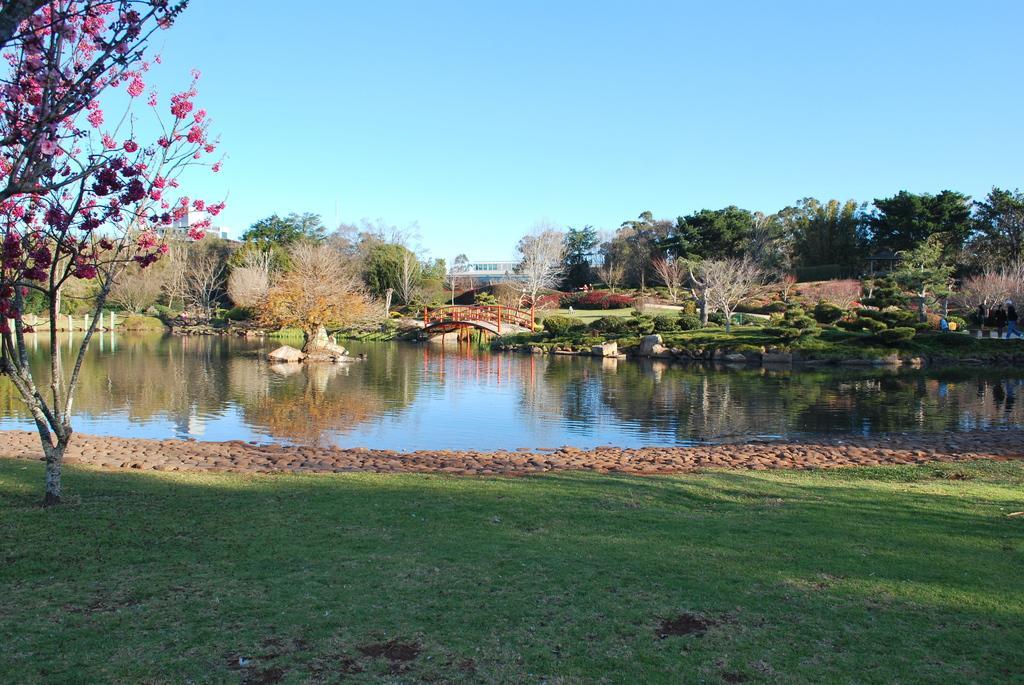Describe this image in one or two sentences. At the bottom of the image there is grass. In the background of the image there are trees, water, bridge, sky. 